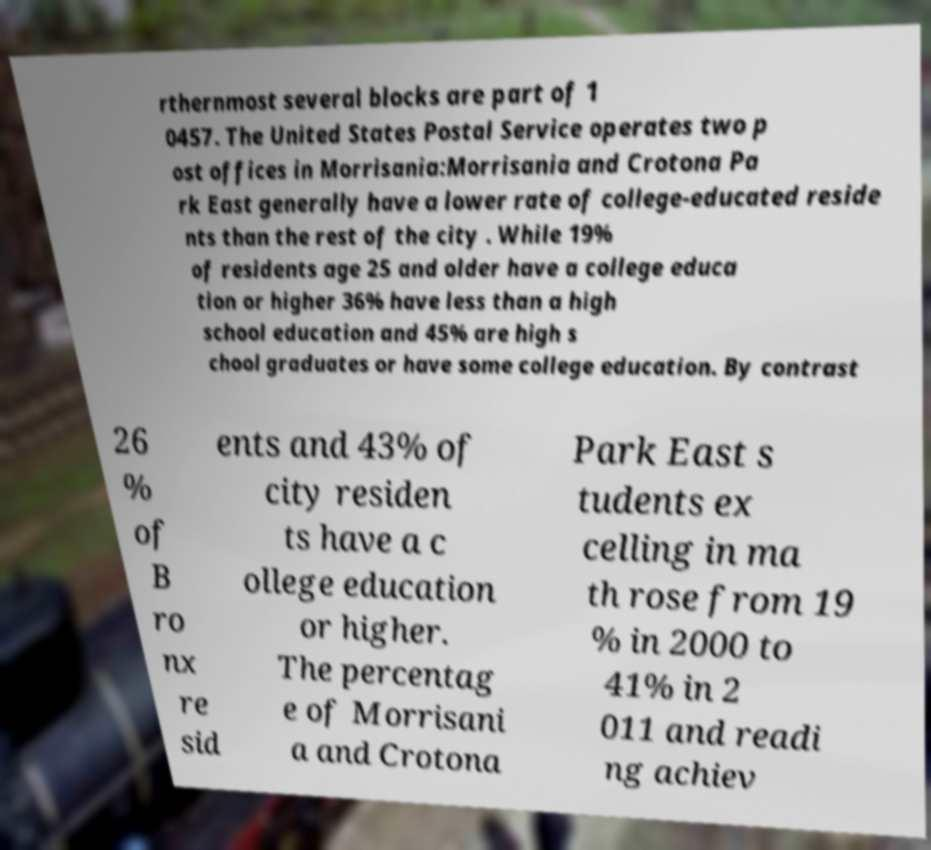I need the written content from this picture converted into text. Can you do that? rthernmost several blocks are part of 1 0457. The United States Postal Service operates two p ost offices in Morrisania:Morrisania and Crotona Pa rk East generally have a lower rate of college-educated reside nts than the rest of the city . While 19% of residents age 25 and older have a college educa tion or higher 36% have less than a high school education and 45% are high s chool graduates or have some college education. By contrast 26 % of B ro nx re sid ents and 43% of city residen ts have a c ollege education or higher. The percentag e of Morrisani a and Crotona Park East s tudents ex celling in ma th rose from 19 % in 2000 to 41% in 2 011 and readi ng achiev 